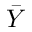<formula> <loc_0><loc_0><loc_500><loc_500>\bar { Y }</formula> 